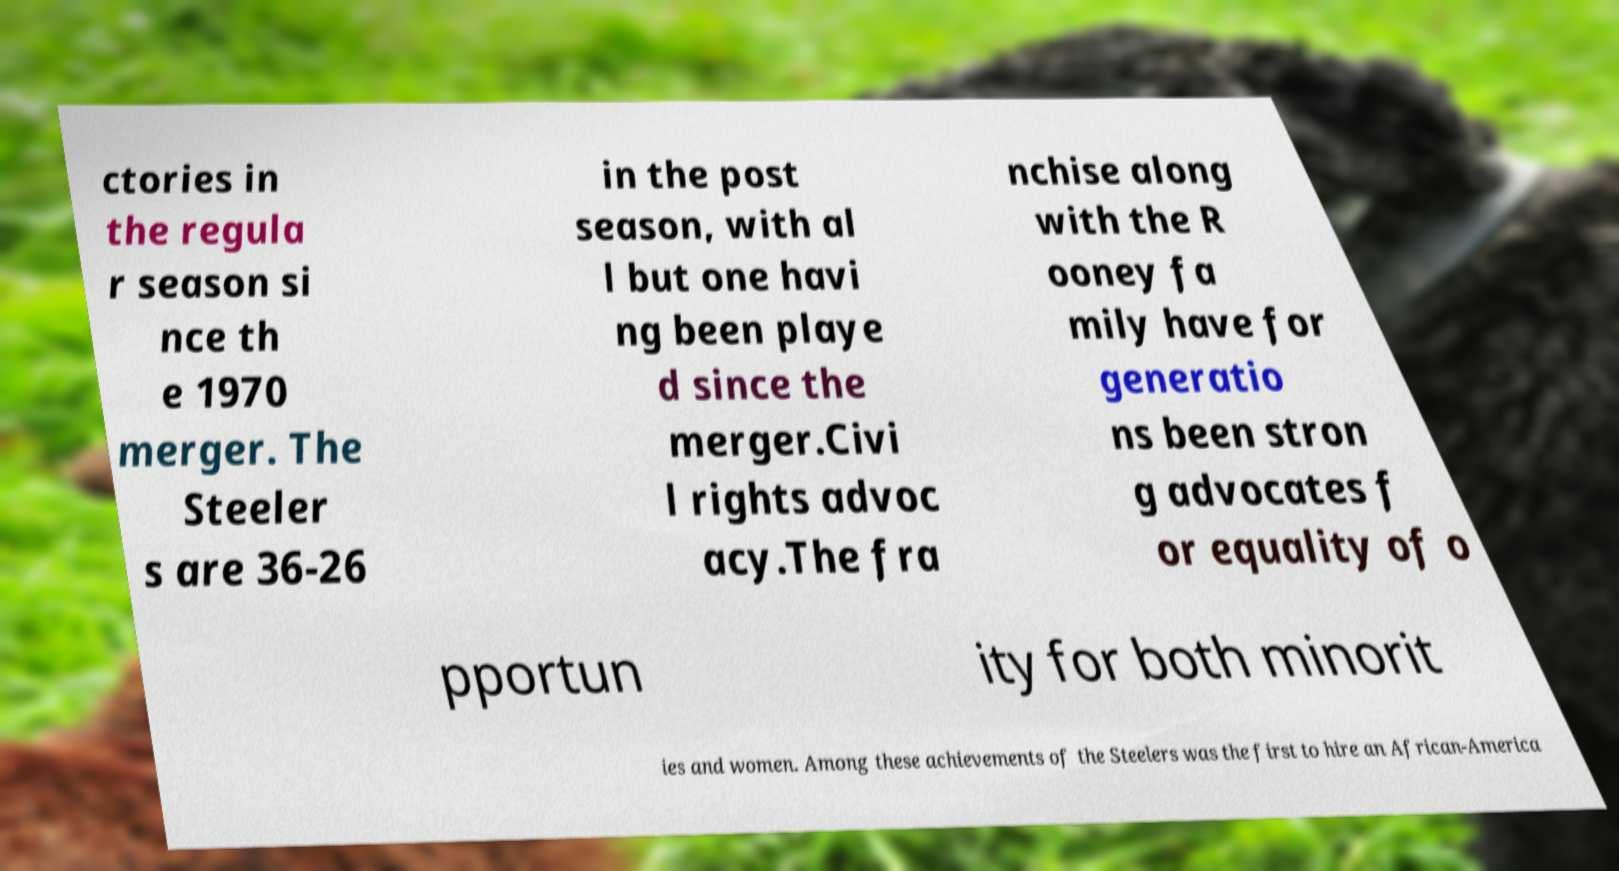Could you extract and type out the text from this image? ctories in the regula r season si nce th e 1970 merger. The Steeler s are 36-26 in the post season, with al l but one havi ng been playe d since the merger.Civi l rights advoc acy.The fra nchise along with the R ooney fa mily have for generatio ns been stron g advocates f or equality of o pportun ity for both minorit ies and women. Among these achievements of the Steelers was the first to hire an African-America 